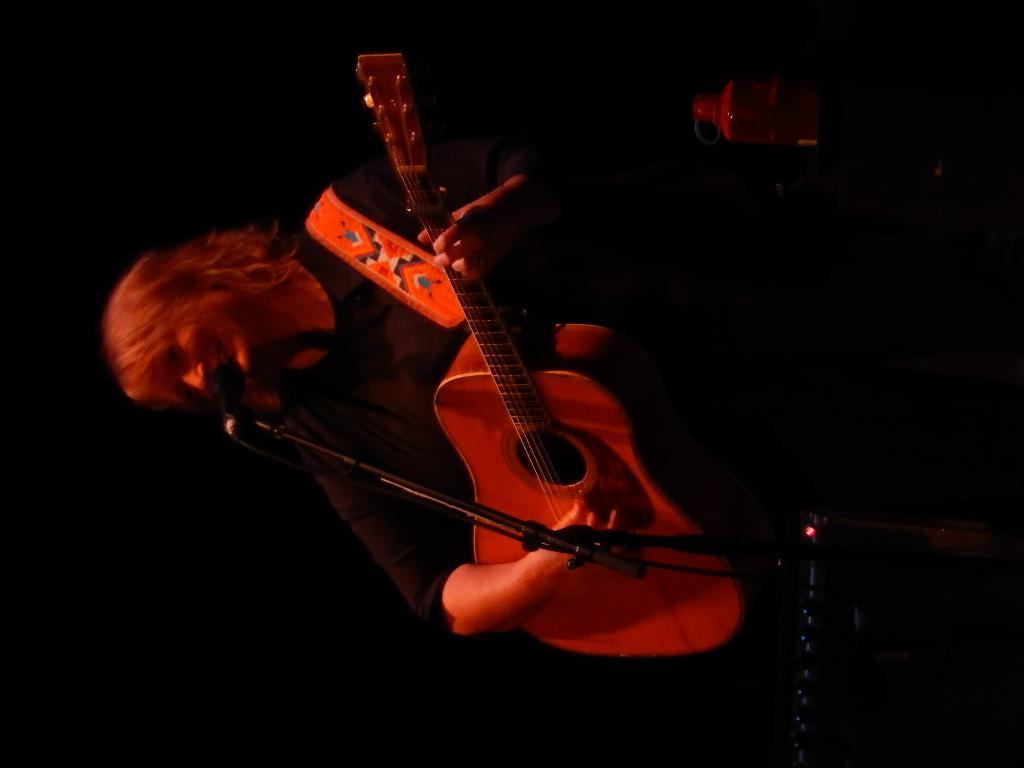What is the main subject of the image? There is a person in the image. What is the person doing in the image? The person is standing and holding a guitar in his hand. What objects can be seen in the background of the image? There is a bottle and a microphone in the background of the image. What type of secretary can be seen working in the cemetery in the image? There is no secretary or cemetery present in the image; it features a person holding a guitar and background objects. 